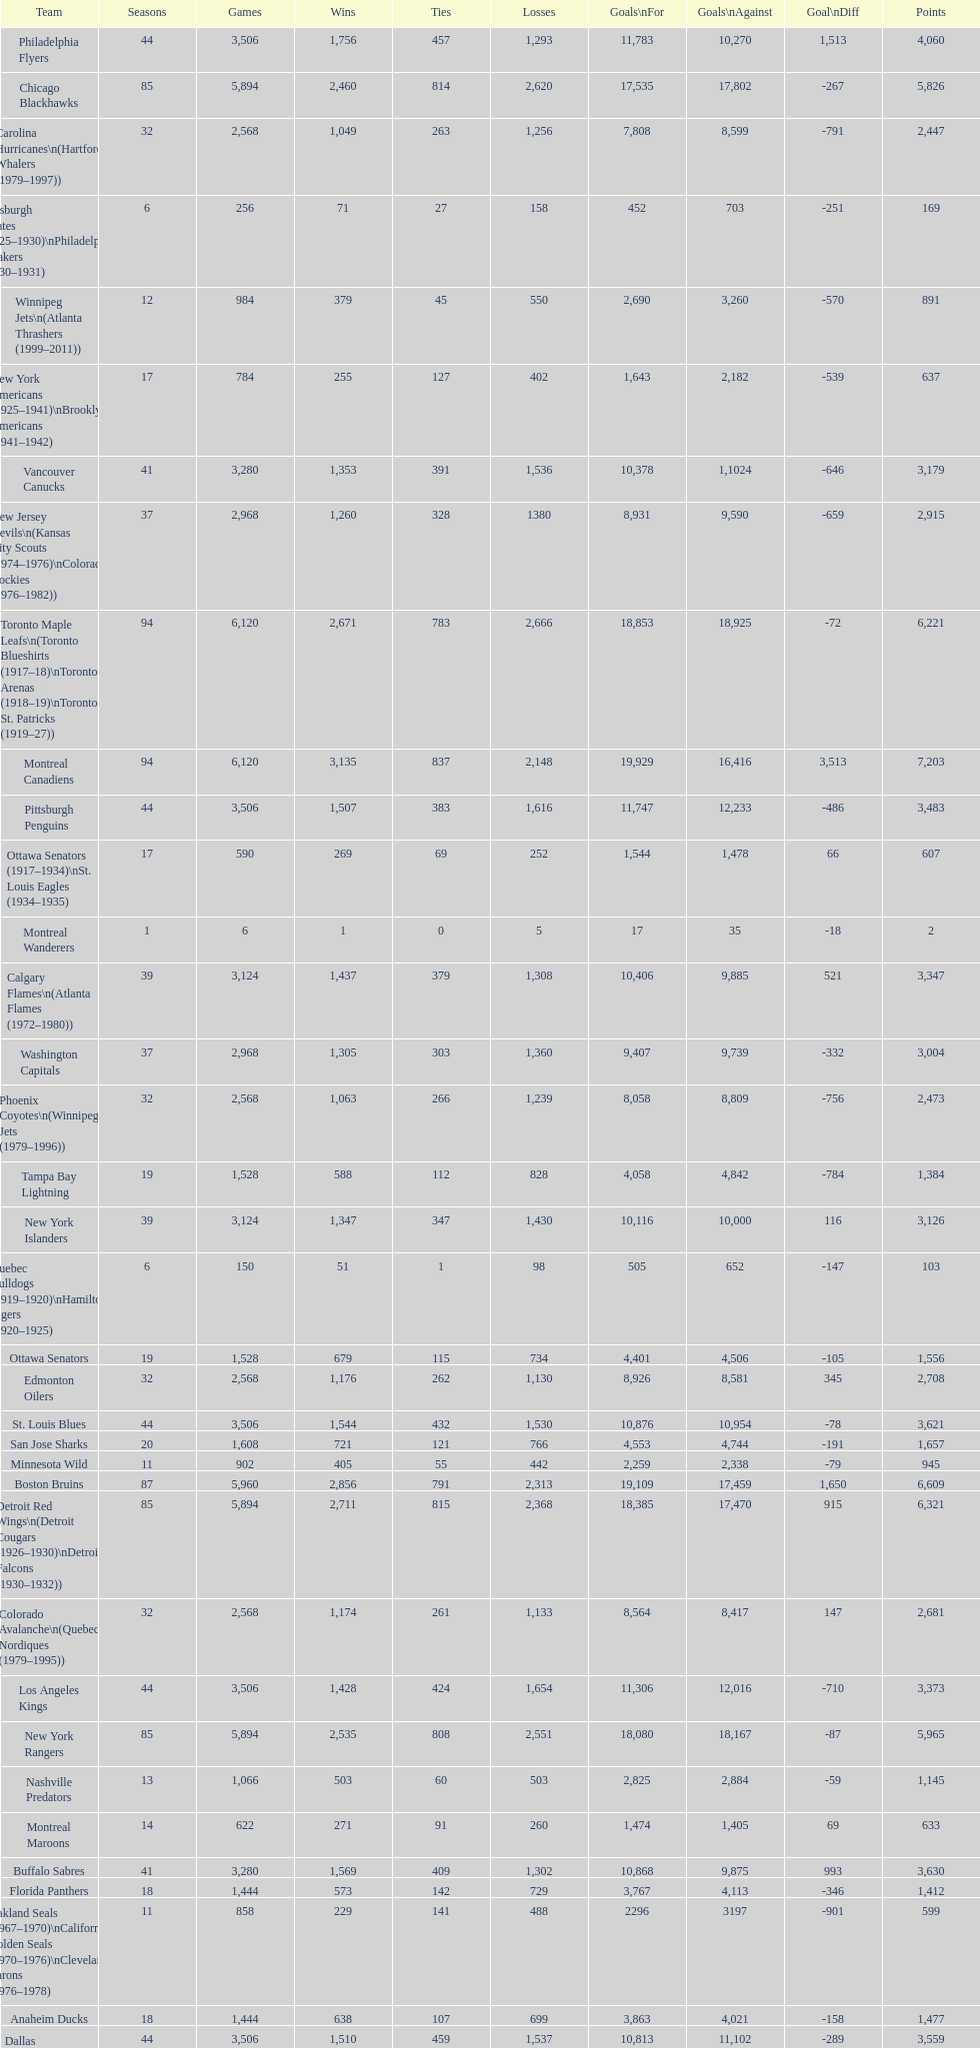Who is at the top of the list? Montreal Canadiens. 